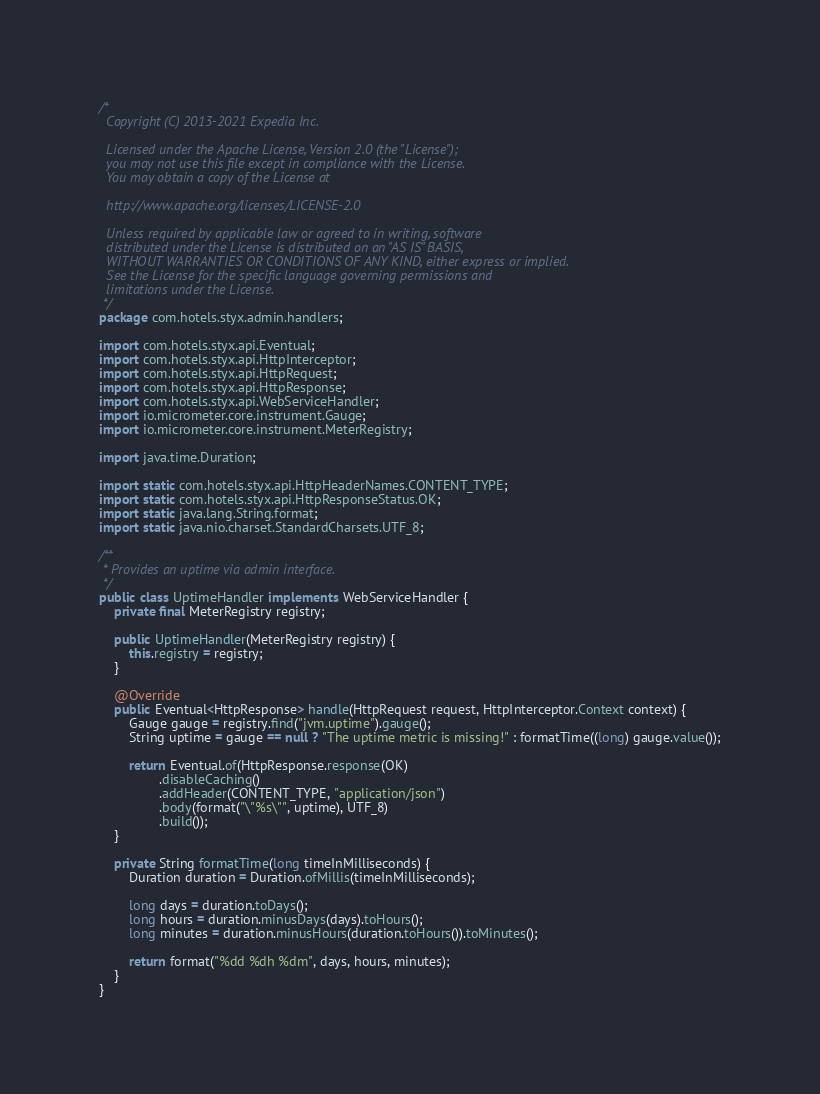<code> <loc_0><loc_0><loc_500><loc_500><_Java_>/*
  Copyright (C) 2013-2021 Expedia Inc.

  Licensed under the Apache License, Version 2.0 (the "License");
  you may not use this file except in compliance with the License.
  You may obtain a copy of the License at

  http://www.apache.org/licenses/LICENSE-2.0

  Unless required by applicable law or agreed to in writing, software
  distributed under the License is distributed on an "AS IS" BASIS,
  WITHOUT WARRANTIES OR CONDITIONS OF ANY KIND, either express or implied.
  See the License for the specific language governing permissions and
  limitations under the License.
 */
package com.hotels.styx.admin.handlers;

import com.hotels.styx.api.Eventual;
import com.hotels.styx.api.HttpInterceptor;
import com.hotels.styx.api.HttpRequest;
import com.hotels.styx.api.HttpResponse;
import com.hotels.styx.api.WebServiceHandler;
import io.micrometer.core.instrument.Gauge;
import io.micrometer.core.instrument.MeterRegistry;

import java.time.Duration;

import static com.hotels.styx.api.HttpHeaderNames.CONTENT_TYPE;
import static com.hotels.styx.api.HttpResponseStatus.OK;
import static java.lang.String.format;
import static java.nio.charset.StandardCharsets.UTF_8;

/**
 * Provides an uptime via admin interface.
 */
public class UptimeHandler implements WebServiceHandler {
    private final MeterRegistry registry;

    public UptimeHandler(MeterRegistry registry) {
        this.registry = registry;
    }

    @Override
    public Eventual<HttpResponse> handle(HttpRequest request, HttpInterceptor.Context context) {
        Gauge gauge = registry.find("jvm.uptime").gauge();
        String uptime = gauge == null ? "The uptime metric is missing!" : formatTime((long) gauge.value());

        return Eventual.of(HttpResponse.response(OK)
                .disableCaching()
                .addHeader(CONTENT_TYPE, "application/json")
                .body(format("\"%s\"", uptime), UTF_8)
                .build());
    }

    private String formatTime(long timeInMilliseconds) {
        Duration duration = Duration.ofMillis(timeInMilliseconds);

        long days = duration.toDays();
        long hours = duration.minusDays(days).toHours();
        long minutes = duration.minusHours(duration.toHours()).toMinutes();

        return format("%dd %dh %dm", days, hours, minutes);
    }
}
</code> 